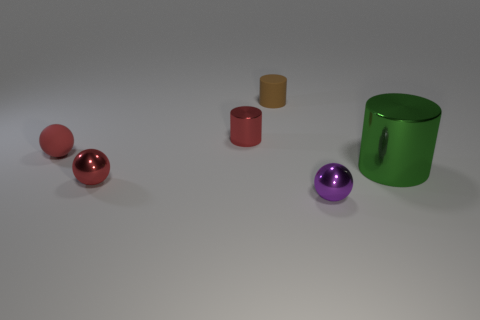Subtract all metallic balls. How many balls are left? 1 Add 3 large green rubber blocks. How many objects exist? 9 Subtract all large green objects. Subtract all tiny purple shiny spheres. How many objects are left? 4 Add 6 large cylinders. How many large cylinders are left? 7 Add 5 small red rubber objects. How many small red rubber objects exist? 6 Subtract 1 red cylinders. How many objects are left? 5 